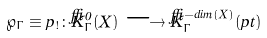Convert formula to latex. <formula><loc_0><loc_0><loc_500><loc_500>\wp _ { \Gamma } \equiv p _ { ! } \colon \check { K } ^ { 0 } _ { \Gamma } ( X ) \longrightarrow \check { K } ^ { - d i m ( X ) } _ { \Gamma } ( p t )</formula> 